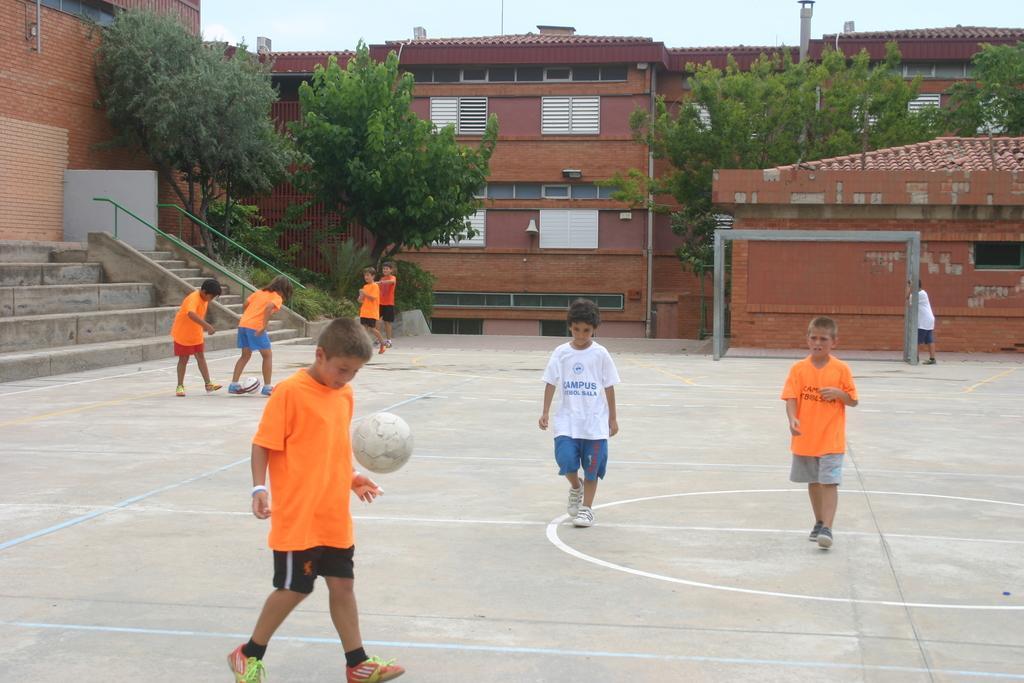Can you describe this image briefly? Here we can see children. Ball is in the air. Background there are buildings, steps, windows and trees. 